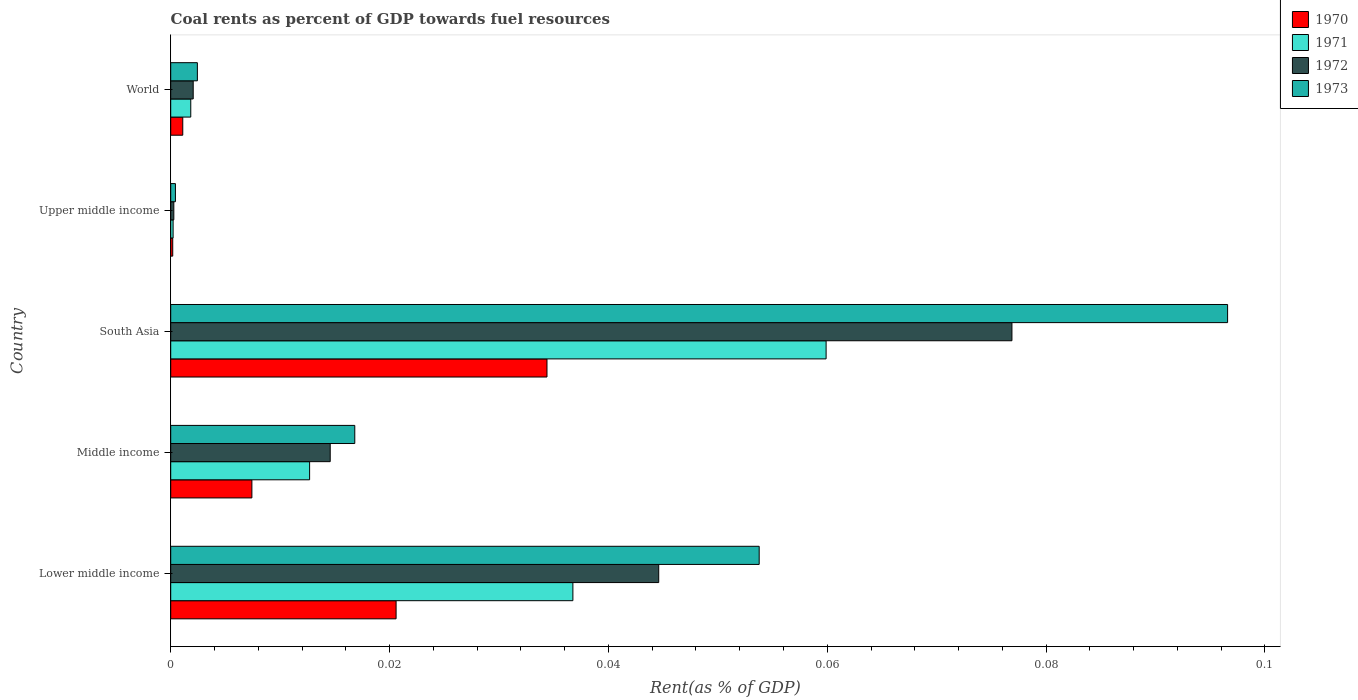Are the number of bars per tick equal to the number of legend labels?
Offer a terse response. Yes. How many bars are there on the 2nd tick from the bottom?
Offer a very short reply. 4. What is the label of the 4th group of bars from the top?
Ensure brevity in your answer.  Middle income. In how many cases, is the number of bars for a given country not equal to the number of legend labels?
Your response must be concise. 0. What is the coal rent in 1971 in World?
Offer a very short reply. 0. Across all countries, what is the maximum coal rent in 1972?
Your response must be concise. 0.08. Across all countries, what is the minimum coal rent in 1971?
Make the answer very short. 0. In which country was the coal rent in 1970 minimum?
Your response must be concise. Upper middle income. What is the total coal rent in 1970 in the graph?
Your answer should be compact. 0.06. What is the difference between the coal rent in 1971 in South Asia and that in World?
Provide a short and direct response. 0.06. What is the difference between the coal rent in 1971 in South Asia and the coal rent in 1972 in Lower middle income?
Provide a short and direct response. 0.02. What is the average coal rent in 1970 per country?
Give a very brief answer. 0.01. What is the difference between the coal rent in 1971 and coal rent in 1973 in Middle income?
Give a very brief answer. -0. In how many countries, is the coal rent in 1971 greater than 0.048 %?
Offer a very short reply. 1. What is the ratio of the coal rent in 1970 in South Asia to that in Upper middle income?
Give a very brief answer. 187.05. What is the difference between the highest and the second highest coal rent in 1970?
Offer a very short reply. 0.01. What is the difference between the highest and the lowest coal rent in 1970?
Make the answer very short. 0.03. Is the sum of the coal rent in 1972 in Middle income and South Asia greater than the maximum coal rent in 1970 across all countries?
Offer a very short reply. Yes. What does the 4th bar from the top in South Asia represents?
Your answer should be very brief. 1970. What does the 1st bar from the bottom in Middle income represents?
Your answer should be compact. 1970. How many bars are there?
Make the answer very short. 20. Does the graph contain any zero values?
Offer a terse response. No. How many legend labels are there?
Your answer should be compact. 4. What is the title of the graph?
Ensure brevity in your answer.  Coal rents as percent of GDP towards fuel resources. Does "1981" appear as one of the legend labels in the graph?
Give a very brief answer. No. What is the label or title of the X-axis?
Provide a succinct answer. Rent(as % of GDP). What is the Rent(as % of GDP) in 1970 in Lower middle income?
Offer a terse response. 0.02. What is the Rent(as % of GDP) in 1971 in Lower middle income?
Provide a succinct answer. 0.04. What is the Rent(as % of GDP) in 1972 in Lower middle income?
Offer a very short reply. 0.04. What is the Rent(as % of GDP) of 1973 in Lower middle income?
Offer a very short reply. 0.05. What is the Rent(as % of GDP) of 1970 in Middle income?
Your answer should be compact. 0.01. What is the Rent(as % of GDP) in 1971 in Middle income?
Offer a terse response. 0.01. What is the Rent(as % of GDP) of 1972 in Middle income?
Make the answer very short. 0.01. What is the Rent(as % of GDP) in 1973 in Middle income?
Give a very brief answer. 0.02. What is the Rent(as % of GDP) in 1970 in South Asia?
Your answer should be very brief. 0.03. What is the Rent(as % of GDP) in 1971 in South Asia?
Provide a succinct answer. 0.06. What is the Rent(as % of GDP) of 1972 in South Asia?
Provide a succinct answer. 0.08. What is the Rent(as % of GDP) in 1973 in South Asia?
Offer a very short reply. 0.1. What is the Rent(as % of GDP) of 1970 in Upper middle income?
Keep it short and to the point. 0. What is the Rent(as % of GDP) in 1971 in Upper middle income?
Your response must be concise. 0. What is the Rent(as % of GDP) of 1972 in Upper middle income?
Your answer should be compact. 0. What is the Rent(as % of GDP) of 1973 in Upper middle income?
Your answer should be compact. 0. What is the Rent(as % of GDP) of 1970 in World?
Keep it short and to the point. 0. What is the Rent(as % of GDP) in 1971 in World?
Your answer should be very brief. 0. What is the Rent(as % of GDP) in 1972 in World?
Ensure brevity in your answer.  0. What is the Rent(as % of GDP) in 1973 in World?
Make the answer very short. 0. Across all countries, what is the maximum Rent(as % of GDP) of 1970?
Your response must be concise. 0.03. Across all countries, what is the maximum Rent(as % of GDP) of 1971?
Provide a short and direct response. 0.06. Across all countries, what is the maximum Rent(as % of GDP) of 1972?
Provide a short and direct response. 0.08. Across all countries, what is the maximum Rent(as % of GDP) in 1973?
Provide a short and direct response. 0.1. Across all countries, what is the minimum Rent(as % of GDP) of 1970?
Provide a short and direct response. 0. Across all countries, what is the minimum Rent(as % of GDP) of 1971?
Offer a very short reply. 0. Across all countries, what is the minimum Rent(as % of GDP) in 1972?
Make the answer very short. 0. Across all countries, what is the minimum Rent(as % of GDP) of 1973?
Offer a very short reply. 0. What is the total Rent(as % of GDP) of 1970 in the graph?
Your answer should be compact. 0.06. What is the total Rent(as % of GDP) in 1971 in the graph?
Keep it short and to the point. 0.11. What is the total Rent(as % of GDP) of 1972 in the graph?
Your answer should be very brief. 0.14. What is the total Rent(as % of GDP) of 1973 in the graph?
Give a very brief answer. 0.17. What is the difference between the Rent(as % of GDP) of 1970 in Lower middle income and that in Middle income?
Provide a succinct answer. 0.01. What is the difference between the Rent(as % of GDP) in 1971 in Lower middle income and that in Middle income?
Your answer should be very brief. 0.02. What is the difference between the Rent(as % of GDP) in 1972 in Lower middle income and that in Middle income?
Give a very brief answer. 0.03. What is the difference between the Rent(as % of GDP) in 1973 in Lower middle income and that in Middle income?
Your response must be concise. 0.04. What is the difference between the Rent(as % of GDP) of 1970 in Lower middle income and that in South Asia?
Your answer should be compact. -0.01. What is the difference between the Rent(as % of GDP) of 1971 in Lower middle income and that in South Asia?
Keep it short and to the point. -0.02. What is the difference between the Rent(as % of GDP) of 1972 in Lower middle income and that in South Asia?
Ensure brevity in your answer.  -0.03. What is the difference between the Rent(as % of GDP) of 1973 in Lower middle income and that in South Asia?
Ensure brevity in your answer.  -0.04. What is the difference between the Rent(as % of GDP) in 1970 in Lower middle income and that in Upper middle income?
Give a very brief answer. 0.02. What is the difference between the Rent(as % of GDP) in 1971 in Lower middle income and that in Upper middle income?
Provide a succinct answer. 0.04. What is the difference between the Rent(as % of GDP) in 1972 in Lower middle income and that in Upper middle income?
Your response must be concise. 0.04. What is the difference between the Rent(as % of GDP) of 1973 in Lower middle income and that in Upper middle income?
Make the answer very short. 0.05. What is the difference between the Rent(as % of GDP) of 1970 in Lower middle income and that in World?
Provide a short and direct response. 0.02. What is the difference between the Rent(as % of GDP) of 1971 in Lower middle income and that in World?
Keep it short and to the point. 0.03. What is the difference between the Rent(as % of GDP) of 1972 in Lower middle income and that in World?
Provide a short and direct response. 0.04. What is the difference between the Rent(as % of GDP) in 1973 in Lower middle income and that in World?
Offer a very short reply. 0.05. What is the difference between the Rent(as % of GDP) in 1970 in Middle income and that in South Asia?
Your answer should be very brief. -0.03. What is the difference between the Rent(as % of GDP) of 1971 in Middle income and that in South Asia?
Your answer should be compact. -0.05. What is the difference between the Rent(as % of GDP) of 1972 in Middle income and that in South Asia?
Make the answer very short. -0.06. What is the difference between the Rent(as % of GDP) in 1973 in Middle income and that in South Asia?
Give a very brief answer. -0.08. What is the difference between the Rent(as % of GDP) in 1970 in Middle income and that in Upper middle income?
Make the answer very short. 0.01. What is the difference between the Rent(as % of GDP) of 1971 in Middle income and that in Upper middle income?
Keep it short and to the point. 0.01. What is the difference between the Rent(as % of GDP) in 1972 in Middle income and that in Upper middle income?
Keep it short and to the point. 0.01. What is the difference between the Rent(as % of GDP) of 1973 in Middle income and that in Upper middle income?
Your answer should be very brief. 0.02. What is the difference between the Rent(as % of GDP) in 1970 in Middle income and that in World?
Keep it short and to the point. 0.01. What is the difference between the Rent(as % of GDP) of 1971 in Middle income and that in World?
Provide a succinct answer. 0.01. What is the difference between the Rent(as % of GDP) of 1972 in Middle income and that in World?
Keep it short and to the point. 0.01. What is the difference between the Rent(as % of GDP) in 1973 in Middle income and that in World?
Your answer should be very brief. 0.01. What is the difference between the Rent(as % of GDP) of 1970 in South Asia and that in Upper middle income?
Offer a very short reply. 0.03. What is the difference between the Rent(as % of GDP) in 1971 in South Asia and that in Upper middle income?
Make the answer very short. 0.06. What is the difference between the Rent(as % of GDP) in 1972 in South Asia and that in Upper middle income?
Provide a short and direct response. 0.08. What is the difference between the Rent(as % of GDP) of 1973 in South Asia and that in Upper middle income?
Ensure brevity in your answer.  0.1. What is the difference between the Rent(as % of GDP) of 1971 in South Asia and that in World?
Keep it short and to the point. 0.06. What is the difference between the Rent(as % of GDP) in 1972 in South Asia and that in World?
Your answer should be very brief. 0.07. What is the difference between the Rent(as % of GDP) of 1973 in South Asia and that in World?
Your answer should be very brief. 0.09. What is the difference between the Rent(as % of GDP) of 1970 in Upper middle income and that in World?
Offer a very short reply. -0. What is the difference between the Rent(as % of GDP) of 1971 in Upper middle income and that in World?
Provide a short and direct response. -0. What is the difference between the Rent(as % of GDP) in 1972 in Upper middle income and that in World?
Offer a terse response. -0. What is the difference between the Rent(as % of GDP) in 1973 in Upper middle income and that in World?
Offer a very short reply. -0. What is the difference between the Rent(as % of GDP) in 1970 in Lower middle income and the Rent(as % of GDP) in 1971 in Middle income?
Offer a terse response. 0.01. What is the difference between the Rent(as % of GDP) of 1970 in Lower middle income and the Rent(as % of GDP) of 1972 in Middle income?
Give a very brief answer. 0.01. What is the difference between the Rent(as % of GDP) of 1970 in Lower middle income and the Rent(as % of GDP) of 1973 in Middle income?
Provide a succinct answer. 0. What is the difference between the Rent(as % of GDP) of 1971 in Lower middle income and the Rent(as % of GDP) of 1972 in Middle income?
Offer a terse response. 0.02. What is the difference between the Rent(as % of GDP) in 1971 in Lower middle income and the Rent(as % of GDP) in 1973 in Middle income?
Keep it short and to the point. 0.02. What is the difference between the Rent(as % of GDP) in 1972 in Lower middle income and the Rent(as % of GDP) in 1973 in Middle income?
Provide a short and direct response. 0.03. What is the difference between the Rent(as % of GDP) in 1970 in Lower middle income and the Rent(as % of GDP) in 1971 in South Asia?
Make the answer very short. -0.04. What is the difference between the Rent(as % of GDP) of 1970 in Lower middle income and the Rent(as % of GDP) of 1972 in South Asia?
Your answer should be compact. -0.06. What is the difference between the Rent(as % of GDP) of 1970 in Lower middle income and the Rent(as % of GDP) of 1973 in South Asia?
Your response must be concise. -0.08. What is the difference between the Rent(as % of GDP) in 1971 in Lower middle income and the Rent(as % of GDP) in 1972 in South Asia?
Provide a succinct answer. -0.04. What is the difference between the Rent(as % of GDP) of 1971 in Lower middle income and the Rent(as % of GDP) of 1973 in South Asia?
Give a very brief answer. -0.06. What is the difference between the Rent(as % of GDP) in 1972 in Lower middle income and the Rent(as % of GDP) in 1973 in South Asia?
Your answer should be compact. -0.05. What is the difference between the Rent(as % of GDP) in 1970 in Lower middle income and the Rent(as % of GDP) in 1971 in Upper middle income?
Provide a short and direct response. 0.02. What is the difference between the Rent(as % of GDP) of 1970 in Lower middle income and the Rent(as % of GDP) of 1972 in Upper middle income?
Your response must be concise. 0.02. What is the difference between the Rent(as % of GDP) in 1970 in Lower middle income and the Rent(as % of GDP) in 1973 in Upper middle income?
Provide a succinct answer. 0.02. What is the difference between the Rent(as % of GDP) of 1971 in Lower middle income and the Rent(as % of GDP) of 1972 in Upper middle income?
Keep it short and to the point. 0.04. What is the difference between the Rent(as % of GDP) of 1971 in Lower middle income and the Rent(as % of GDP) of 1973 in Upper middle income?
Offer a very short reply. 0.04. What is the difference between the Rent(as % of GDP) of 1972 in Lower middle income and the Rent(as % of GDP) of 1973 in Upper middle income?
Provide a short and direct response. 0.04. What is the difference between the Rent(as % of GDP) of 1970 in Lower middle income and the Rent(as % of GDP) of 1971 in World?
Give a very brief answer. 0.02. What is the difference between the Rent(as % of GDP) in 1970 in Lower middle income and the Rent(as % of GDP) in 1972 in World?
Offer a terse response. 0.02. What is the difference between the Rent(as % of GDP) of 1970 in Lower middle income and the Rent(as % of GDP) of 1973 in World?
Your response must be concise. 0.02. What is the difference between the Rent(as % of GDP) in 1971 in Lower middle income and the Rent(as % of GDP) in 1972 in World?
Offer a terse response. 0.03. What is the difference between the Rent(as % of GDP) of 1971 in Lower middle income and the Rent(as % of GDP) of 1973 in World?
Keep it short and to the point. 0.03. What is the difference between the Rent(as % of GDP) of 1972 in Lower middle income and the Rent(as % of GDP) of 1973 in World?
Provide a short and direct response. 0.04. What is the difference between the Rent(as % of GDP) of 1970 in Middle income and the Rent(as % of GDP) of 1971 in South Asia?
Offer a terse response. -0.05. What is the difference between the Rent(as % of GDP) in 1970 in Middle income and the Rent(as % of GDP) in 1972 in South Asia?
Give a very brief answer. -0.07. What is the difference between the Rent(as % of GDP) in 1970 in Middle income and the Rent(as % of GDP) in 1973 in South Asia?
Provide a succinct answer. -0.09. What is the difference between the Rent(as % of GDP) in 1971 in Middle income and the Rent(as % of GDP) in 1972 in South Asia?
Give a very brief answer. -0.06. What is the difference between the Rent(as % of GDP) of 1971 in Middle income and the Rent(as % of GDP) of 1973 in South Asia?
Provide a succinct answer. -0.08. What is the difference between the Rent(as % of GDP) in 1972 in Middle income and the Rent(as % of GDP) in 1973 in South Asia?
Provide a short and direct response. -0.08. What is the difference between the Rent(as % of GDP) of 1970 in Middle income and the Rent(as % of GDP) of 1971 in Upper middle income?
Make the answer very short. 0.01. What is the difference between the Rent(as % of GDP) of 1970 in Middle income and the Rent(as % of GDP) of 1972 in Upper middle income?
Provide a short and direct response. 0.01. What is the difference between the Rent(as % of GDP) in 1970 in Middle income and the Rent(as % of GDP) in 1973 in Upper middle income?
Your response must be concise. 0.01. What is the difference between the Rent(as % of GDP) in 1971 in Middle income and the Rent(as % of GDP) in 1972 in Upper middle income?
Your answer should be compact. 0.01. What is the difference between the Rent(as % of GDP) of 1971 in Middle income and the Rent(as % of GDP) of 1973 in Upper middle income?
Your answer should be compact. 0.01. What is the difference between the Rent(as % of GDP) of 1972 in Middle income and the Rent(as % of GDP) of 1973 in Upper middle income?
Offer a very short reply. 0.01. What is the difference between the Rent(as % of GDP) in 1970 in Middle income and the Rent(as % of GDP) in 1971 in World?
Give a very brief answer. 0.01. What is the difference between the Rent(as % of GDP) of 1970 in Middle income and the Rent(as % of GDP) of 1972 in World?
Offer a terse response. 0.01. What is the difference between the Rent(as % of GDP) in 1970 in Middle income and the Rent(as % of GDP) in 1973 in World?
Your answer should be compact. 0.01. What is the difference between the Rent(as % of GDP) of 1971 in Middle income and the Rent(as % of GDP) of 1972 in World?
Ensure brevity in your answer.  0.01. What is the difference between the Rent(as % of GDP) in 1971 in Middle income and the Rent(as % of GDP) in 1973 in World?
Your answer should be very brief. 0.01. What is the difference between the Rent(as % of GDP) in 1972 in Middle income and the Rent(as % of GDP) in 1973 in World?
Keep it short and to the point. 0.01. What is the difference between the Rent(as % of GDP) of 1970 in South Asia and the Rent(as % of GDP) of 1971 in Upper middle income?
Your response must be concise. 0.03. What is the difference between the Rent(as % of GDP) of 1970 in South Asia and the Rent(as % of GDP) of 1972 in Upper middle income?
Make the answer very short. 0.03. What is the difference between the Rent(as % of GDP) in 1970 in South Asia and the Rent(as % of GDP) in 1973 in Upper middle income?
Give a very brief answer. 0.03. What is the difference between the Rent(as % of GDP) of 1971 in South Asia and the Rent(as % of GDP) of 1972 in Upper middle income?
Give a very brief answer. 0.06. What is the difference between the Rent(as % of GDP) of 1971 in South Asia and the Rent(as % of GDP) of 1973 in Upper middle income?
Your response must be concise. 0.06. What is the difference between the Rent(as % of GDP) of 1972 in South Asia and the Rent(as % of GDP) of 1973 in Upper middle income?
Provide a short and direct response. 0.08. What is the difference between the Rent(as % of GDP) of 1970 in South Asia and the Rent(as % of GDP) of 1971 in World?
Ensure brevity in your answer.  0.03. What is the difference between the Rent(as % of GDP) in 1970 in South Asia and the Rent(as % of GDP) in 1972 in World?
Make the answer very short. 0.03. What is the difference between the Rent(as % of GDP) of 1970 in South Asia and the Rent(as % of GDP) of 1973 in World?
Your answer should be compact. 0.03. What is the difference between the Rent(as % of GDP) in 1971 in South Asia and the Rent(as % of GDP) in 1972 in World?
Make the answer very short. 0.06. What is the difference between the Rent(as % of GDP) of 1971 in South Asia and the Rent(as % of GDP) of 1973 in World?
Your response must be concise. 0.06. What is the difference between the Rent(as % of GDP) in 1972 in South Asia and the Rent(as % of GDP) in 1973 in World?
Your response must be concise. 0.07. What is the difference between the Rent(as % of GDP) in 1970 in Upper middle income and the Rent(as % of GDP) in 1971 in World?
Ensure brevity in your answer.  -0. What is the difference between the Rent(as % of GDP) in 1970 in Upper middle income and the Rent(as % of GDP) in 1972 in World?
Your answer should be very brief. -0. What is the difference between the Rent(as % of GDP) in 1970 in Upper middle income and the Rent(as % of GDP) in 1973 in World?
Keep it short and to the point. -0. What is the difference between the Rent(as % of GDP) of 1971 in Upper middle income and the Rent(as % of GDP) of 1972 in World?
Your response must be concise. -0. What is the difference between the Rent(as % of GDP) of 1971 in Upper middle income and the Rent(as % of GDP) of 1973 in World?
Ensure brevity in your answer.  -0. What is the difference between the Rent(as % of GDP) of 1972 in Upper middle income and the Rent(as % of GDP) of 1973 in World?
Ensure brevity in your answer.  -0. What is the average Rent(as % of GDP) in 1970 per country?
Give a very brief answer. 0.01. What is the average Rent(as % of GDP) of 1971 per country?
Your answer should be compact. 0.02. What is the average Rent(as % of GDP) in 1972 per country?
Keep it short and to the point. 0.03. What is the average Rent(as % of GDP) in 1973 per country?
Your response must be concise. 0.03. What is the difference between the Rent(as % of GDP) in 1970 and Rent(as % of GDP) in 1971 in Lower middle income?
Provide a short and direct response. -0.02. What is the difference between the Rent(as % of GDP) of 1970 and Rent(as % of GDP) of 1972 in Lower middle income?
Your answer should be very brief. -0.02. What is the difference between the Rent(as % of GDP) in 1970 and Rent(as % of GDP) in 1973 in Lower middle income?
Your answer should be compact. -0.03. What is the difference between the Rent(as % of GDP) of 1971 and Rent(as % of GDP) of 1972 in Lower middle income?
Give a very brief answer. -0.01. What is the difference between the Rent(as % of GDP) of 1971 and Rent(as % of GDP) of 1973 in Lower middle income?
Offer a very short reply. -0.02. What is the difference between the Rent(as % of GDP) of 1972 and Rent(as % of GDP) of 1973 in Lower middle income?
Provide a short and direct response. -0.01. What is the difference between the Rent(as % of GDP) of 1970 and Rent(as % of GDP) of 1971 in Middle income?
Your answer should be compact. -0.01. What is the difference between the Rent(as % of GDP) of 1970 and Rent(as % of GDP) of 1972 in Middle income?
Keep it short and to the point. -0.01. What is the difference between the Rent(as % of GDP) in 1970 and Rent(as % of GDP) in 1973 in Middle income?
Offer a terse response. -0.01. What is the difference between the Rent(as % of GDP) in 1971 and Rent(as % of GDP) in 1972 in Middle income?
Give a very brief answer. -0. What is the difference between the Rent(as % of GDP) of 1971 and Rent(as % of GDP) of 1973 in Middle income?
Offer a very short reply. -0. What is the difference between the Rent(as % of GDP) of 1972 and Rent(as % of GDP) of 1973 in Middle income?
Provide a short and direct response. -0. What is the difference between the Rent(as % of GDP) in 1970 and Rent(as % of GDP) in 1971 in South Asia?
Your answer should be very brief. -0.03. What is the difference between the Rent(as % of GDP) in 1970 and Rent(as % of GDP) in 1972 in South Asia?
Provide a succinct answer. -0.04. What is the difference between the Rent(as % of GDP) in 1970 and Rent(as % of GDP) in 1973 in South Asia?
Your answer should be compact. -0.06. What is the difference between the Rent(as % of GDP) of 1971 and Rent(as % of GDP) of 1972 in South Asia?
Provide a short and direct response. -0.02. What is the difference between the Rent(as % of GDP) of 1971 and Rent(as % of GDP) of 1973 in South Asia?
Your response must be concise. -0.04. What is the difference between the Rent(as % of GDP) in 1972 and Rent(as % of GDP) in 1973 in South Asia?
Make the answer very short. -0.02. What is the difference between the Rent(as % of GDP) in 1970 and Rent(as % of GDP) in 1972 in Upper middle income?
Keep it short and to the point. -0. What is the difference between the Rent(as % of GDP) in 1970 and Rent(as % of GDP) in 1973 in Upper middle income?
Make the answer very short. -0. What is the difference between the Rent(as % of GDP) in 1971 and Rent(as % of GDP) in 1972 in Upper middle income?
Provide a short and direct response. -0. What is the difference between the Rent(as % of GDP) in 1971 and Rent(as % of GDP) in 1973 in Upper middle income?
Give a very brief answer. -0. What is the difference between the Rent(as % of GDP) in 1972 and Rent(as % of GDP) in 1973 in Upper middle income?
Make the answer very short. -0. What is the difference between the Rent(as % of GDP) of 1970 and Rent(as % of GDP) of 1971 in World?
Offer a very short reply. -0. What is the difference between the Rent(as % of GDP) of 1970 and Rent(as % of GDP) of 1972 in World?
Offer a very short reply. -0. What is the difference between the Rent(as % of GDP) in 1970 and Rent(as % of GDP) in 1973 in World?
Your response must be concise. -0. What is the difference between the Rent(as % of GDP) in 1971 and Rent(as % of GDP) in 1972 in World?
Make the answer very short. -0. What is the difference between the Rent(as % of GDP) of 1971 and Rent(as % of GDP) of 1973 in World?
Keep it short and to the point. -0. What is the difference between the Rent(as % of GDP) in 1972 and Rent(as % of GDP) in 1973 in World?
Provide a succinct answer. -0. What is the ratio of the Rent(as % of GDP) of 1970 in Lower middle income to that in Middle income?
Keep it short and to the point. 2.78. What is the ratio of the Rent(as % of GDP) in 1971 in Lower middle income to that in Middle income?
Offer a terse response. 2.9. What is the ratio of the Rent(as % of GDP) in 1972 in Lower middle income to that in Middle income?
Offer a terse response. 3.06. What is the ratio of the Rent(as % of GDP) of 1973 in Lower middle income to that in Middle income?
Give a very brief answer. 3.2. What is the ratio of the Rent(as % of GDP) of 1970 in Lower middle income to that in South Asia?
Make the answer very short. 0.6. What is the ratio of the Rent(as % of GDP) of 1971 in Lower middle income to that in South Asia?
Make the answer very short. 0.61. What is the ratio of the Rent(as % of GDP) in 1972 in Lower middle income to that in South Asia?
Provide a succinct answer. 0.58. What is the ratio of the Rent(as % of GDP) in 1973 in Lower middle income to that in South Asia?
Your answer should be compact. 0.56. What is the ratio of the Rent(as % of GDP) in 1970 in Lower middle income to that in Upper middle income?
Make the answer very short. 112.03. What is the ratio of the Rent(as % of GDP) in 1971 in Lower middle income to that in Upper middle income?
Your answer should be very brief. 167.98. What is the ratio of the Rent(as % of GDP) in 1972 in Lower middle income to that in Upper middle income?
Provide a succinct answer. 156.82. What is the ratio of the Rent(as % of GDP) in 1973 in Lower middle income to that in Upper middle income?
Give a very brief answer. 124.82. What is the ratio of the Rent(as % of GDP) in 1970 in Lower middle income to that in World?
Make the answer very short. 18.71. What is the ratio of the Rent(as % of GDP) of 1971 in Lower middle income to that in World?
Provide a short and direct response. 20.06. What is the ratio of the Rent(as % of GDP) of 1972 in Lower middle income to that in World?
Ensure brevity in your answer.  21.7. What is the ratio of the Rent(as % of GDP) of 1973 in Lower middle income to that in World?
Offer a very short reply. 22.07. What is the ratio of the Rent(as % of GDP) in 1970 in Middle income to that in South Asia?
Your answer should be compact. 0.22. What is the ratio of the Rent(as % of GDP) of 1971 in Middle income to that in South Asia?
Your response must be concise. 0.21. What is the ratio of the Rent(as % of GDP) of 1972 in Middle income to that in South Asia?
Provide a succinct answer. 0.19. What is the ratio of the Rent(as % of GDP) in 1973 in Middle income to that in South Asia?
Keep it short and to the point. 0.17. What is the ratio of the Rent(as % of GDP) of 1970 in Middle income to that in Upper middle income?
Your answer should be compact. 40.36. What is the ratio of the Rent(as % of GDP) of 1971 in Middle income to that in Upper middle income?
Provide a short and direct response. 58.01. What is the ratio of the Rent(as % of GDP) of 1972 in Middle income to that in Upper middle income?
Give a very brief answer. 51.25. What is the ratio of the Rent(as % of GDP) of 1973 in Middle income to that in Upper middle income?
Provide a short and direct response. 39.04. What is the ratio of the Rent(as % of GDP) in 1970 in Middle income to that in World?
Your response must be concise. 6.74. What is the ratio of the Rent(as % of GDP) of 1971 in Middle income to that in World?
Provide a succinct answer. 6.93. What is the ratio of the Rent(as % of GDP) of 1972 in Middle income to that in World?
Offer a very short reply. 7.09. What is the ratio of the Rent(as % of GDP) in 1973 in Middle income to that in World?
Provide a short and direct response. 6.91. What is the ratio of the Rent(as % of GDP) of 1970 in South Asia to that in Upper middle income?
Your answer should be compact. 187.05. What is the ratio of the Rent(as % of GDP) in 1971 in South Asia to that in Upper middle income?
Your answer should be compact. 273.74. What is the ratio of the Rent(as % of GDP) in 1972 in South Asia to that in Upper middle income?
Offer a terse response. 270.32. What is the ratio of the Rent(as % of GDP) of 1973 in South Asia to that in Upper middle income?
Give a very brief answer. 224.18. What is the ratio of the Rent(as % of GDP) in 1970 in South Asia to that in World?
Your answer should be compact. 31.24. What is the ratio of the Rent(as % of GDP) of 1971 in South Asia to that in World?
Your answer should be compact. 32.69. What is the ratio of the Rent(as % of GDP) in 1972 in South Asia to that in World?
Ensure brevity in your answer.  37.41. What is the ratio of the Rent(as % of GDP) of 1973 in South Asia to that in World?
Provide a short and direct response. 39.65. What is the ratio of the Rent(as % of GDP) in 1970 in Upper middle income to that in World?
Ensure brevity in your answer.  0.17. What is the ratio of the Rent(as % of GDP) in 1971 in Upper middle income to that in World?
Your response must be concise. 0.12. What is the ratio of the Rent(as % of GDP) in 1972 in Upper middle income to that in World?
Provide a succinct answer. 0.14. What is the ratio of the Rent(as % of GDP) of 1973 in Upper middle income to that in World?
Your answer should be very brief. 0.18. What is the difference between the highest and the second highest Rent(as % of GDP) in 1970?
Give a very brief answer. 0.01. What is the difference between the highest and the second highest Rent(as % of GDP) of 1971?
Your answer should be very brief. 0.02. What is the difference between the highest and the second highest Rent(as % of GDP) in 1972?
Offer a terse response. 0.03. What is the difference between the highest and the second highest Rent(as % of GDP) in 1973?
Your response must be concise. 0.04. What is the difference between the highest and the lowest Rent(as % of GDP) of 1970?
Offer a terse response. 0.03. What is the difference between the highest and the lowest Rent(as % of GDP) of 1971?
Make the answer very short. 0.06. What is the difference between the highest and the lowest Rent(as % of GDP) of 1972?
Your response must be concise. 0.08. What is the difference between the highest and the lowest Rent(as % of GDP) in 1973?
Offer a very short reply. 0.1. 